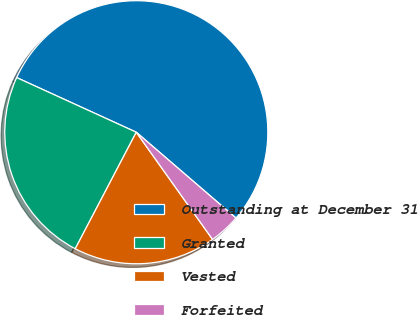<chart> <loc_0><loc_0><loc_500><loc_500><pie_chart><fcel>Outstanding at December 31<fcel>Granted<fcel>Vested<fcel>Forfeited<nl><fcel>54.49%<fcel>24.14%<fcel>17.52%<fcel>3.85%<nl></chart> 